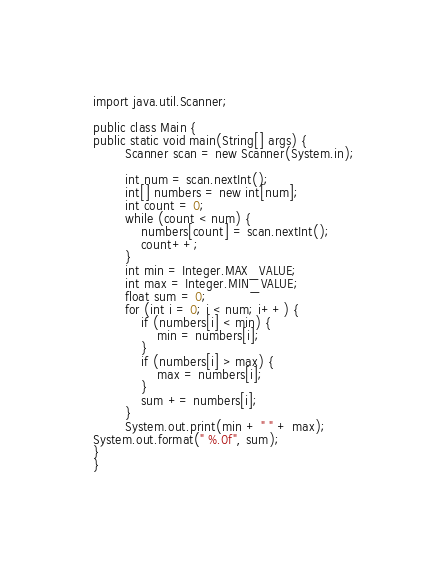<code> <loc_0><loc_0><loc_500><loc_500><_Java_>import java.util.Scanner;

public class Main {
public static void main(String[] args) {
		Scanner scan = new Scanner(System.in);

		int num = scan.nextInt();
		int[] numbers = new int[num];
		int count = 0;
		while (count < num) {
			numbers[count] = scan.nextInt();
			count++;
		}
		int min = Integer.MAX_VALUE;
		int max = Integer.MIN_VALUE;
		float sum = 0;
		for (int i = 0; i < num; i++) {
			if (numbers[i] < min) {
				min = numbers[i];
			}
			if (numbers[i] > max) {
				max = numbers[i];
			}
			sum += numbers[i];
		}
		System.out.print(min + " " + max);
System.out.format(" %.0f", sum);
} 
}



</code> 